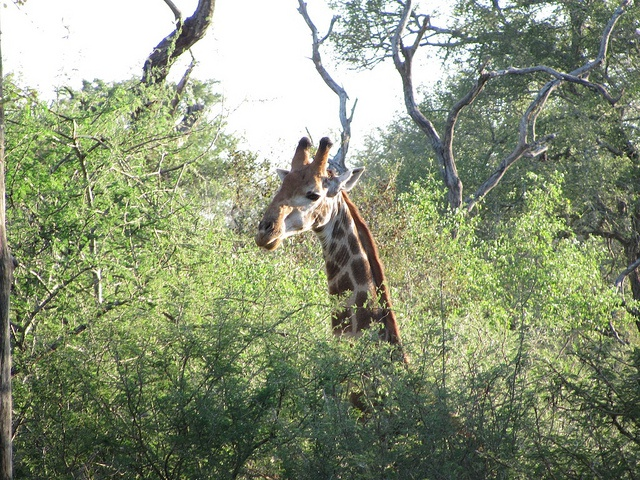Describe the objects in this image and their specific colors. I can see a giraffe in white, gray, black, and ivory tones in this image. 